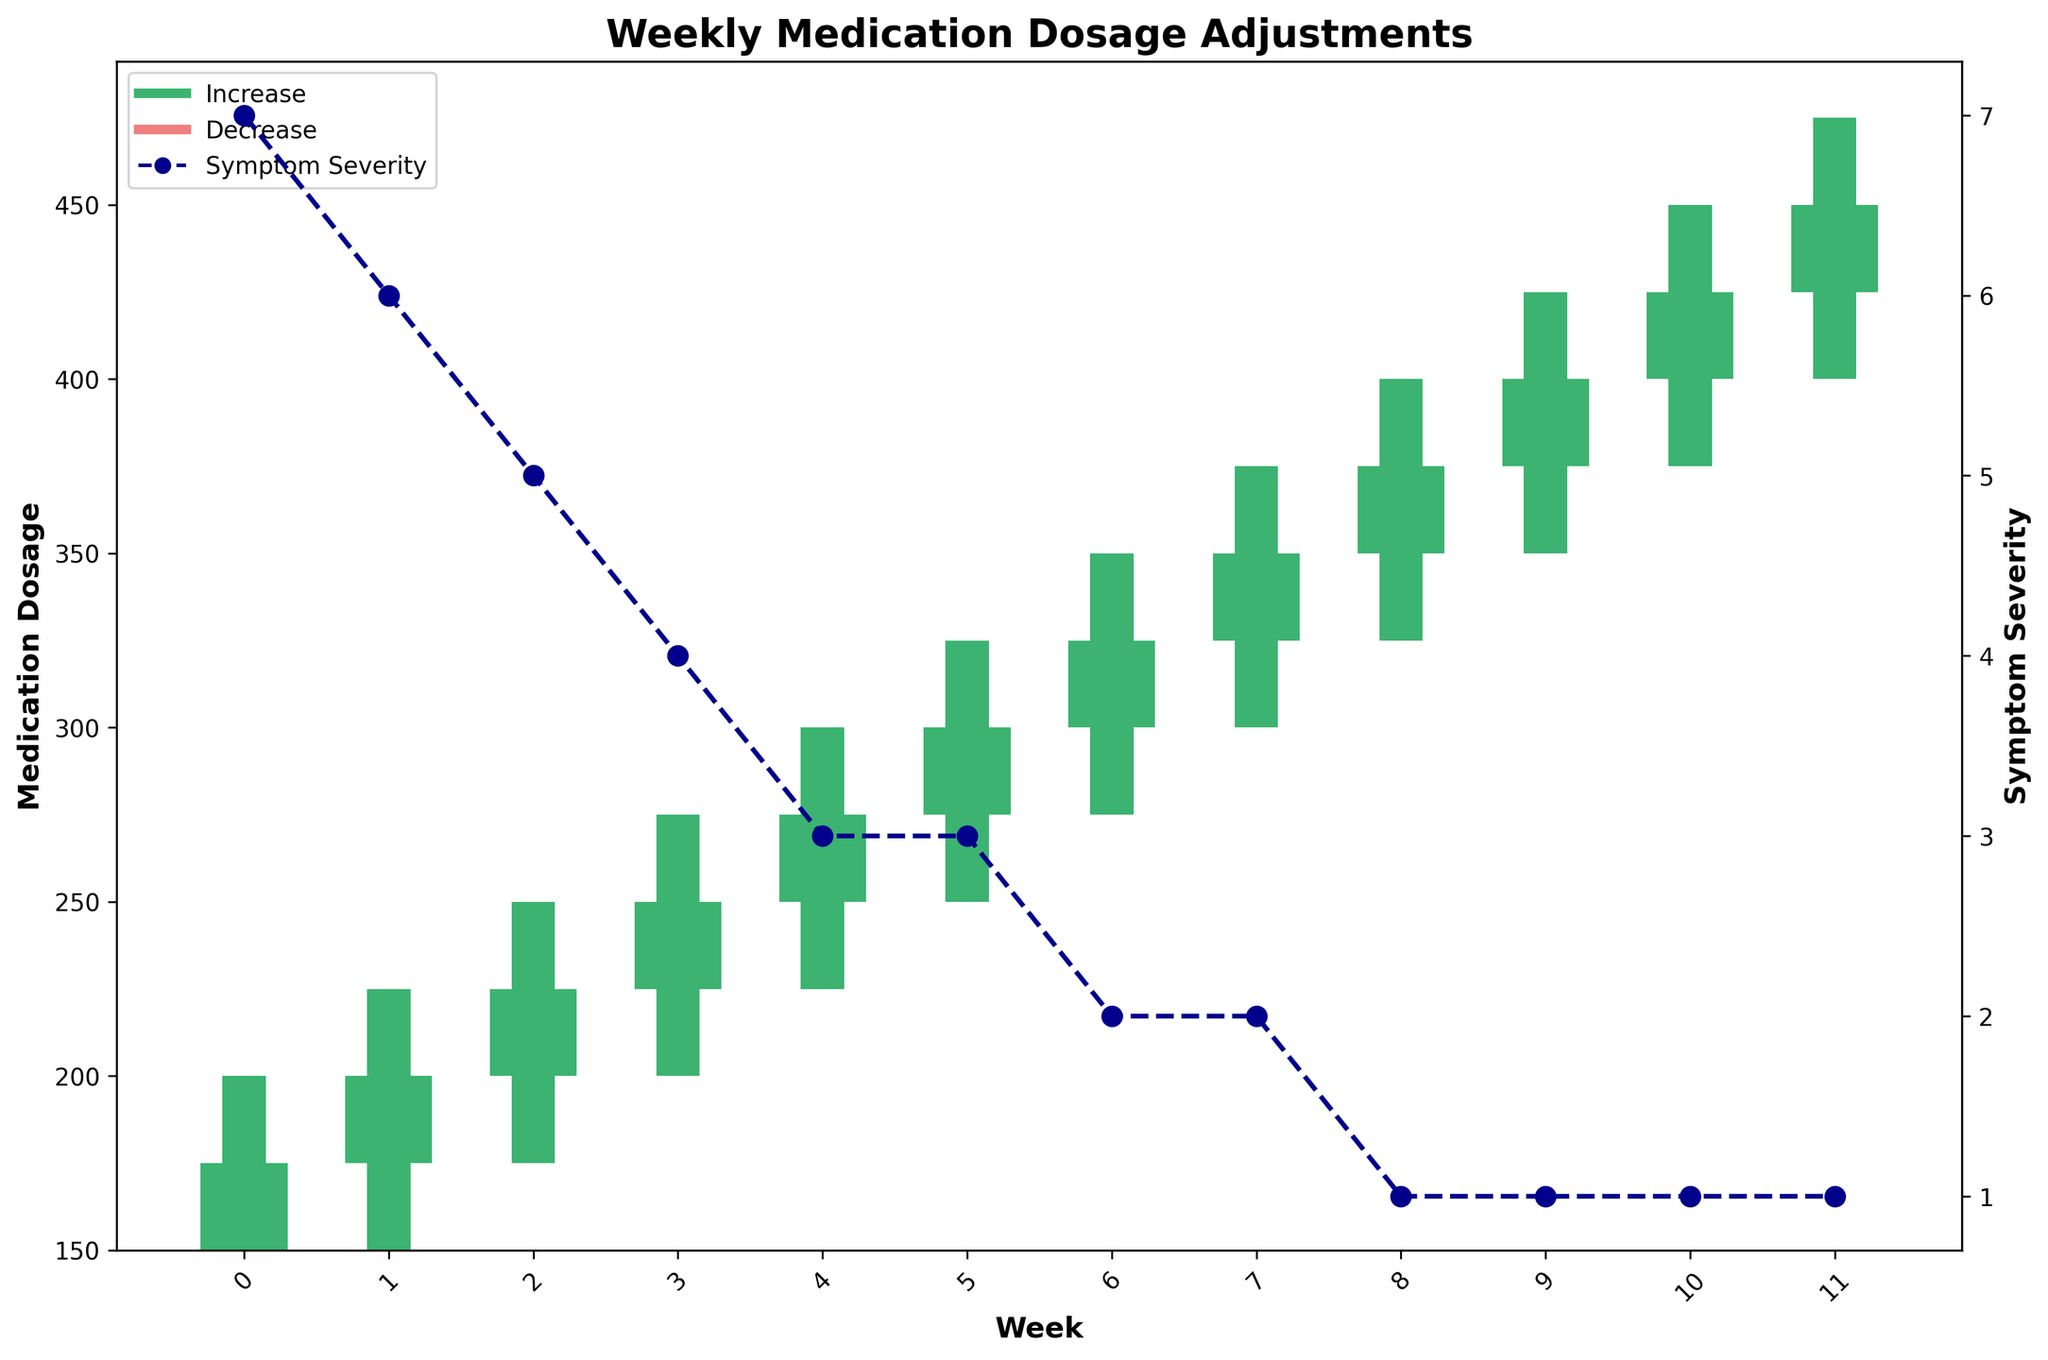What is the title of the figure? The title of the figure is found at the top center and describes the main focus of the plot.
Answer: "Weekly Medication Dosage Adjustments" What does the blue dashed line with circles represent? The blue dashed line with circles represents the second y-axis labeled "Symptom Severity," indicating changes in symptom severity over the weeks.
Answer: Symptom Severity How many weeks are displayed in the figure? The x-axis ticks indicate the number of weeks displayed in the figure. Counting these ticks gives the total number of weeks.
Answer: 12 What is the highest medication dosage recorded in the figure? The dosage can be found by looking at the highest point on the y-axis labeled "Medication Dosage."
Answer: 475 In which week did both the lowest and highest "Symptom Severity" occur? The lowest "Symptom Severity" is 1, occurring multiple times, and the highest is 7. The weeks can be determined by finding respective blue circle points on the plot.
Answer: Weeks 1 and 12 for low, Week 1 for high How did the medication dosage change from Week 1 to Week 4? The medication dosage increased each week from Week 1 to Week 4. The open, close, high, and low points for these weeks can be checked visually.
Answer: It increased How many weeks have a medication dosage decrease? The decrease in medication dosage is indicated by the color red. Counting the number of red bars provides the number of weeks with a decrease.
Answer: 0 What is the median "Symptom Severity" across the 12 weeks? Arrange the "Symptom Severity" values in ascending order and find the middle value. (1, 1, 1, 1, 2, 2, 3, 3, 4, 5, 6, 7)
Answer: 2.5 Compare Week 5 and Week 7 in terms of symptom severity and medication dosage. Week 5 has a "Symptom Severity" of 3, and Week 7 has a severity of 2. The close medication dosages can be checked visually for these weeks.
Answer: Week 5 has higher symptoms, Week 7 has higher dosage What trend do you notice in symptom severity as the medication dosage increases? Generally, the "Symptom Severity" decreases as the "Medication Dosage" increases. Observing the decreasing blue dashed line with the increasing bars of medication dosage supports this trend.
Answer: Severity decreases 